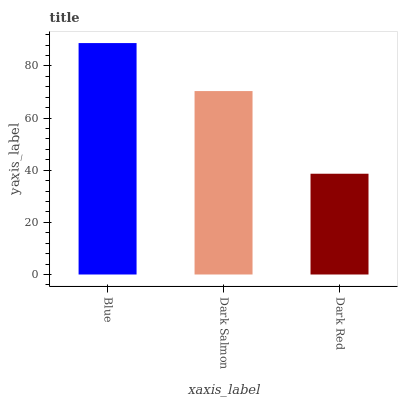Is Dark Red the minimum?
Answer yes or no. Yes. Is Blue the maximum?
Answer yes or no. Yes. Is Dark Salmon the minimum?
Answer yes or no. No. Is Dark Salmon the maximum?
Answer yes or no. No. Is Blue greater than Dark Salmon?
Answer yes or no. Yes. Is Dark Salmon less than Blue?
Answer yes or no. Yes. Is Dark Salmon greater than Blue?
Answer yes or no. No. Is Blue less than Dark Salmon?
Answer yes or no. No. Is Dark Salmon the high median?
Answer yes or no. Yes. Is Dark Salmon the low median?
Answer yes or no. Yes. Is Blue the high median?
Answer yes or no. No. Is Dark Red the low median?
Answer yes or no. No. 